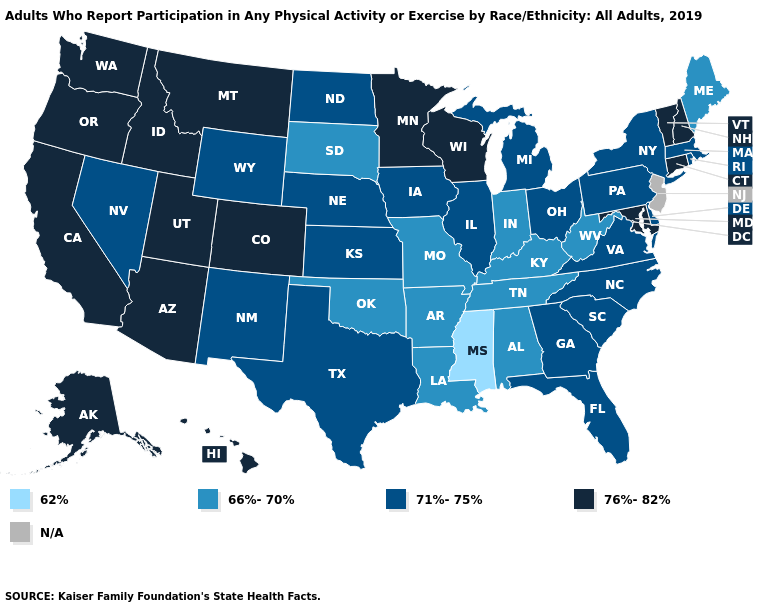Name the states that have a value in the range 76%-82%?
Write a very short answer. Alaska, Arizona, California, Colorado, Connecticut, Hawaii, Idaho, Maryland, Minnesota, Montana, New Hampshire, Oregon, Utah, Vermont, Washington, Wisconsin. What is the value of North Carolina?
Short answer required. 71%-75%. What is the value of Tennessee?
Write a very short answer. 66%-70%. Name the states that have a value in the range 71%-75%?
Keep it brief. Delaware, Florida, Georgia, Illinois, Iowa, Kansas, Massachusetts, Michigan, Nebraska, Nevada, New Mexico, New York, North Carolina, North Dakota, Ohio, Pennsylvania, Rhode Island, South Carolina, Texas, Virginia, Wyoming. Is the legend a continuous bar?
Write a very short answer. No. Name the states that have a value in the range N/A?
Answer briefly. New Jersey. Which states have the highest value in the USA?
Write a very short answer. Alaska, Arizona, California, Colorado, Connecticut, Hawaii, Idaho, Maryland, Minnesota, Montana, New Hampshire, Oregon, Utah, Vermont, Washington, Wisconsin. How many symbols are there in the legend?
Keep it brief. 5. What is the highest value in the South ?
Be succinct. 76%-82%. Does the first symbol in the legend represent the smallest category?
Concise answer only. Yes. Which states have the highest value in the USA?
Quick response, please. Alaska, Arizona, California, Colorado, Connecticut, Hawaii, Idaho, Maryland, Minnesota, Montana, New Hampshire, Oregon, Utah, Vermont, Washington, Wisconsin. Which states have the lowest value in the South?
Concise answer only. Mississippi. What is the value of Idaho?
Answer briefly. 76%-82%. Does Maine have the lowest value in the Northeast?
Concise answer only. Yes. 